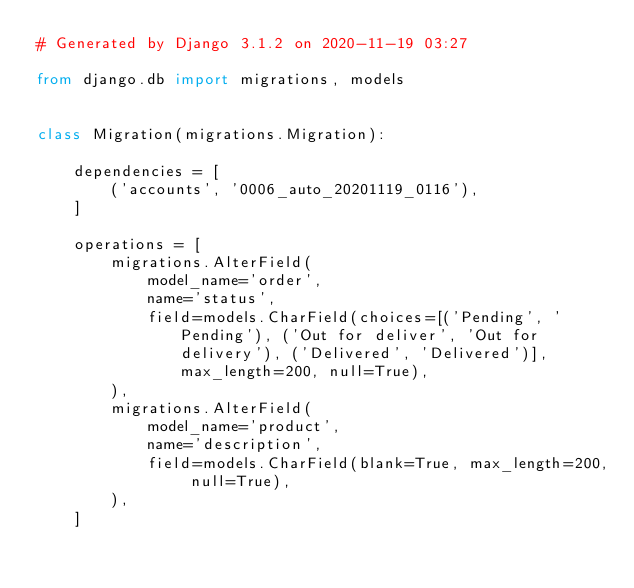<code> <loc_0><loc_0><loc_500><loc_500><_Python_># Generated by Django 3.1.2 on 2020-11-19 03:27

from django.db import migrations, models


class Migration(migrations.Migration):

    dependencies = [
        ('accounts', '0006_auto_20201119_0116'),
    ]

    operations = [
        migrations.AlterField(
            model_name='order',
            name='status',
            field=models.CharField(choices=[('Pending', 'Pending'), ('Out for deliver', 'Out for delivery'), ('Delivered', 'Delivered')], max_length=200, null=True),
        ),
        migrations.AlterField(
            model_name='product',
            name='description',
            field=models.CharField(blank=True, max_length=200, null=True),
        ),
    ]
</code> 